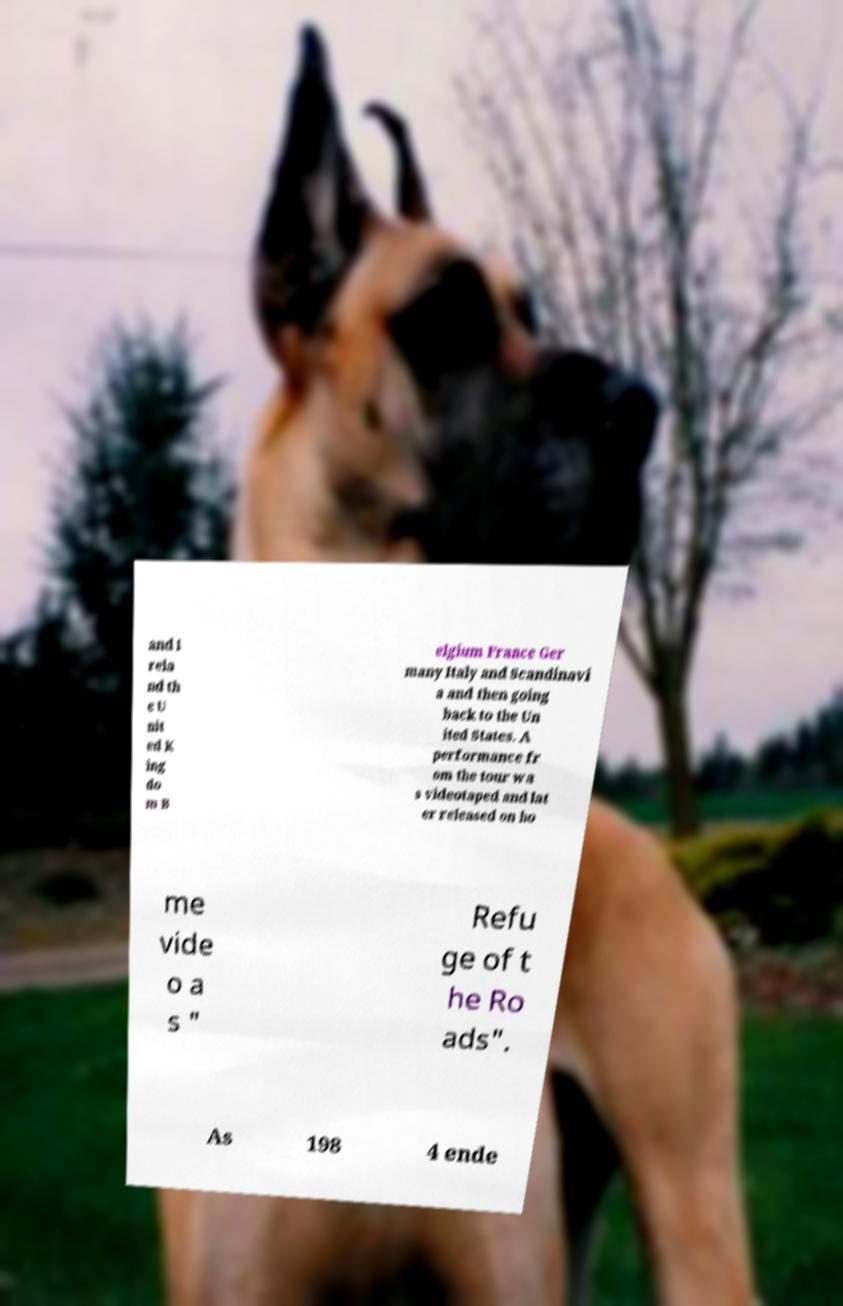I need the written content from this picture converted into text. Can you do that? and I rela nd th e U nit ed K ing do m B elgium France Ger many Italy and Scandinavi a and then going back to the Un ited States. A performance fr om the tour wa s videotaped and lat er released on ho me vide o a s " Refu ge of t he Ro ads". As 198 4 ende 